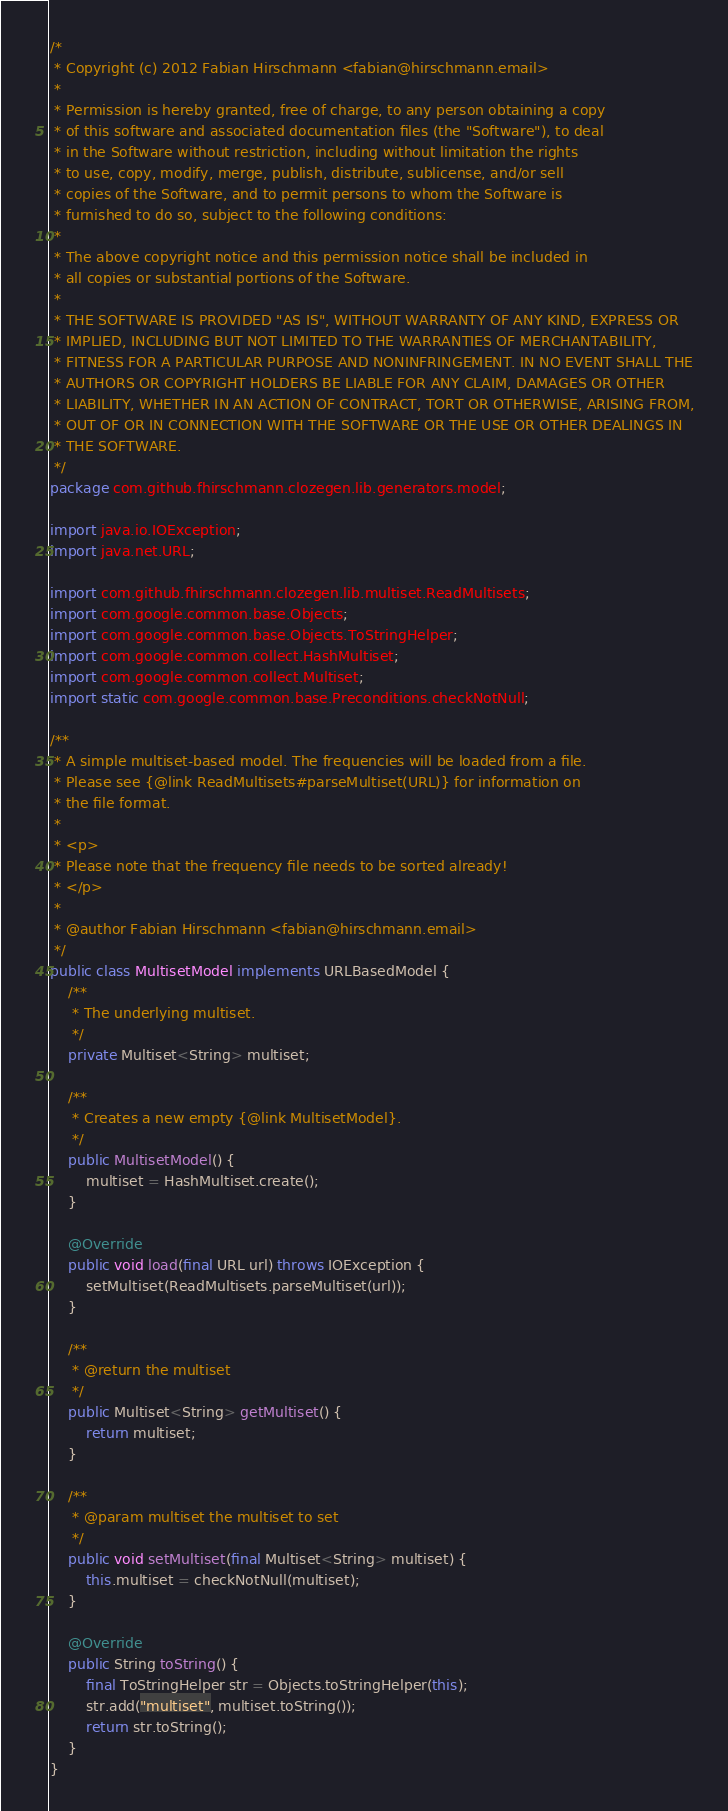<code> <loc_0><loc_0><loc_500><loc_500><_Java_>/*
 * Copyright (c) 2012 Fabian Hirschmann <fabian@hirschmann.email>
 *
 * Permission is hereby granted, free of charge, to any person obtaining a copy
 * of this software and associated documentation files (the "Software"), to deal
 * in the Software without restriction, including without limitation the rights
 * to use, copy, modify, merge, publish, distribute, sublicense, and/or sell
 * copies of the Software, and to permit persons to whom the Software is
 * furnished to do so, subject to the following conditions:
 *
 * The above copyright notice and this permission notice shall be included in
 * all copies or substantial portions of the Software.
 *
 * THE SOFTWARE IS PROVIDED "AS IS", WITHOUT WARRANTY OF ANY KIND, EXPRESS OR
 * IMPLIED, INCLUDING BUT NOT LIMITED TO THE WARRANTIES OF MERCHANTABILITY,
 * FITNESS FOR A PARTICULAR PURPOSE AND NONINFRINGEMENT. IN NO EVENT SHALL THE
 * AUTHORS OR COPYRIGHT HOLDERS BE LIABLE FOR ANY CLAIM, DAMAGES OR OTHER
 * LIABILITY, WHETHER IN AN ACTION OF CONTRACT, TORT OR OTHERWISE, ARISING FROM,
 * OUT OF OR IN CONNECTION WITH THE SOFTWARE OR THE USE OR OTHER DEALINGS IN
 * THE SOFTWARE.
 */
package com.github.fhirschmann.clozegen.lib.generators.model;

import java.io.IOException;
import java.net.URL;

import com.github.fhirschmann.clozegen.lib.multiset.ReadMultisets;
import com.google.common.base.Objects;
import com.google.common.base.Objects.ToStringHelper;
import com.google.common.collect.HashMultiset;
import com.google.common.collect.Multiset;
import static com.google.common.base.Preconditions.checkNotNull;

/**
 * A simple multiset-based model. The frequencies will be loaded from a file.
 * Please see {@link ReadMultisets#parseMultiset(URL)} for information on
 * the file format.
 *
 * <p>
 * Please note that the frequency file needs to be sorted already!
 * </p>
 *
 * @author Fabian Hirschmann <fabian@hirschmann.email>
 */
public class MultisetModel implements URLBasedModel {
    /**
     * The underlying multiset.
     */
    private Multiset<String> multiset;

    /**
     * Creates a new empty {@link MultisetModel}.
     */
    public MultisetModel() {
        multiset = HashMultiset.create();
    }

    @Override
    public void load(final URL url) throws IOException {
        setMultiset(ReadMultisets.parseMultiset(url));
    }

    /**
     * @return the multiset
     */
    public Multiset<String> getMultiset() {
        return multiset;
    }

    /**
     * @param multiset the multiset to set
     */
    public void setMultiset(final Multiset<String> multiset) {
        this.multiset = checkNotNull(multiset);
    }

    @Override
    public String toString() {
        final ToStringHelper str = Objects.toStringHelper(this);
        str.add("multiset", multiset.toString());
        return str.toString();
    }
}
</code> 